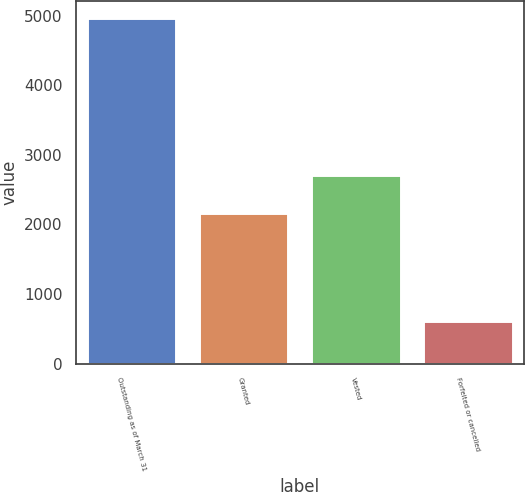Convert chart to OTSL. <chart><loc_0><loc_0><loc_500><loc_500><bar_chart><fcel>Outstanding as of March 31<fcel>Granted<fcel>Vested<fcel>Forfeited or cancelled<nl><fcel>4960<fcel>2169<fcel>2702.2<fcel>616<nl></chart> 